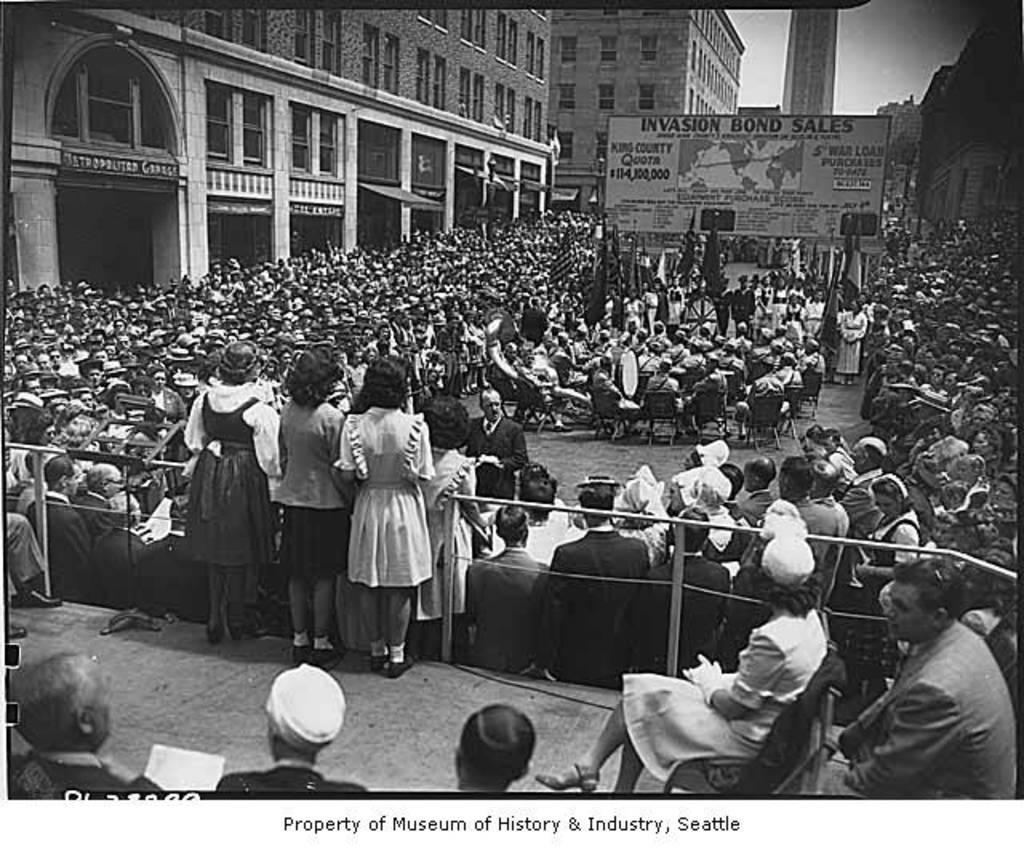Describe this image in one or two sentences. In the picture we can see group of people standing, in the middle of the picture there are some people sitting on chairs and in the background of the picture there is board, there are some buildings. 